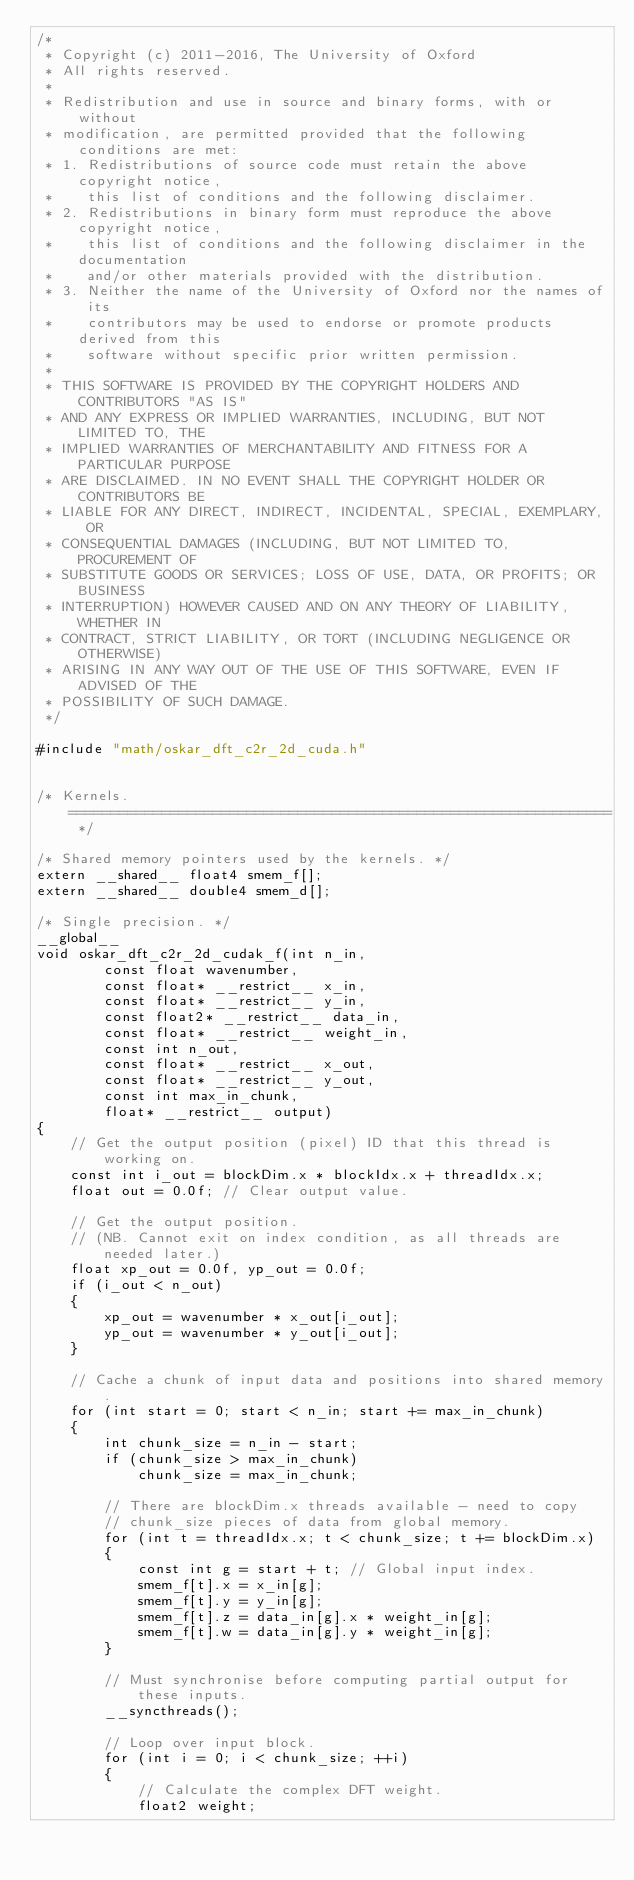Convert code to text. <code><loc_0><loc_0><loc_500><loc_500><_Cuda_>/*
 * Copyright (c) 2011-2016, The University of Oxford
 * All rights reserved.
 *
 * Redistribution and use in source and binary forms, with or without
 * modification, are permitted provided that the following conditions are met:
 * 1. Redistributions of source code must retain the above copyright notice,
 *    this list of conditions and the following disclaimer.
 * 2. Redistributions in binary form must reproduce the above copyright notice,
 *    this list of conditions and the following disclaimer in the documentation
 *    and/or other materials provided with the distribution.
 * 3. Neither the name of the University of Oxford nor the names of its
 *    contributors may be used to endorse or promote products derived from this
 *    software without specific prior written permission.
 *
 * THIS SOFTWARE IS PROVIDED BY THE COPYRIGHT HOLDERS AND CONTRIBUTORS "AS IS"
 * AND ANY EXPRESS OR IMPLIED WARRANTIES, INCLUDING, BUT NOT LIMITED TO, THE
 * IMPLIED WARRANTIES OF MERCHANTABILITY AND FITNESS FOR A PARTICULAR PURPOSE
 * ARE DISCLAIMED. IN NO EVENT SHALL THE COPYRIGHT HOLDER OR CONTRIBUTORS BE
 * LIABLE FOR ANY DIRECT, INDIRECT, INCIDENTAL, SPECIAL, EXEMPLARY, OR
 * CONSEQUENTIAL DAMAGES (INCLUDING, BUT NOT LIMITED TO, PROCUREMENT OF
 * SUBSTITUTE GOODS OR SERVICES; LOSS OF USE, DATA, OR PROFITS; OR BUSINESS
 * INTERRUPTION) HOWEVER CAUSED AND ON ANY THEORY OF LIABILITY, WHETHER IN
 * CONTRACT, STRICT LIABILITY, OR TORT (INCLUDING NEGLIGENCE OR OTHERWISE)
 * ARISING IN ANY WAY OUT OF THE USE OF THIS SOFTWARE, EVEN IF ADVISED OF THE
 * POSSIBILITY OF SUCH DAMAGE.
 */

#include "math/oskar_dft_c2r_2d_cuda.h"


/* Kernels. ================================================================ */

/* Shared memory pointers used by the kernels. */
extern __shared__ float4 smem_f[];
extern __shared__ double4 smem_d[];

/* Single precision. */
__global__
void oskar_dft_c2r_2d_cudak_f(int n_in,
        const float wavenumber,
        const float* __restrict__ x_in,
        const float* __restrict__ y_in,
        const float2* __restrict__ data_in,
        const float* __restrict__ weight_in,
        const int n_out,
        const float* __restrict__ x_out,
        const float* __restrict__ y_out,
        const int max_in_chunk,
        float* __restrict__ output)
{
    // Get the output position (pixel) ID that this thread is working on.
    const int i_out = blockDim.x * blockIdx.x + threadIdx.x;
    float out = 0.0f; // Clear output value.

    // Get the output position.
    // (NB. Cannot exit on index condition, as all threads are needed later.)
    float xp_out = 0.0f, yp_out = 0.0f;
    if (i_out < n_out)
    {
        xp_out = wavenumber * x_out[i_out];
        yp_out = wavenumber * y_out[i_out];
    }

    // Cache a chunk of input data and positions into shared memory.
    for (int start = 0; start < n_in; start += max_in_chunk)
    {
        int chunk_size = n_in - start;
        if (chunk_size > max_in_chunk)
            chunk_size = max_in_chunk;

        // There are blockDim.x threads available - need to copy
        // chunk_size pieces of data from global memory.
        for (int t = threadIdx.x; t < chunk_size; t += blockDim.x)
        {
            const int g = start + t; // Global input index.
            smem_f[t].x = x_in[g];
            smem_f[t].y = y_in[g];
            smem_f[t].z = data_in[g].x * weight_in[g];
            smem_f[t].w = data_in[g].y * weight_in[g];
        }

        // Must synchronise before computing partial output for these inputs.
        __syncthreads();

        // Loop over input block.
        for (int i = 0; i < chunk_size; ++i)
        {
            // Calculate the complex DFT weight.
            float2 weight;</code> 